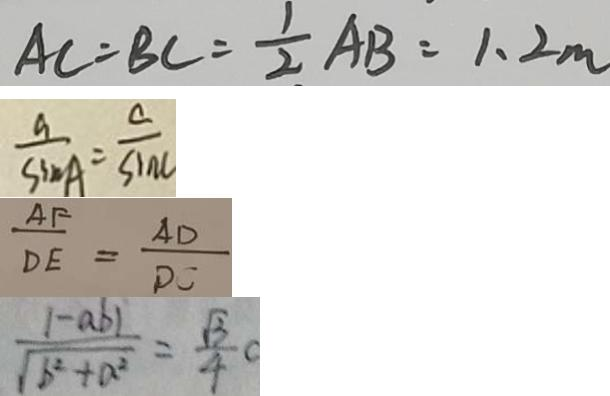Convert formula to latex. <formula><loc_0><loc_0><loc_500><loc_500>A C = B C = \frac { 1 } { 2 } A B = 1 . 2 m 
 \frac { a } { \sin A } = \frac { c } { \sin C } 
 \frac { A F } { D E } = \frac { A D } { D C } 
 \frac { \vert - a b \vert } { \sqrt { b ^ { 2 } + a ^ { 2 } } } = \frac { \sqrt { 3 } } { 4 } c</formula> 